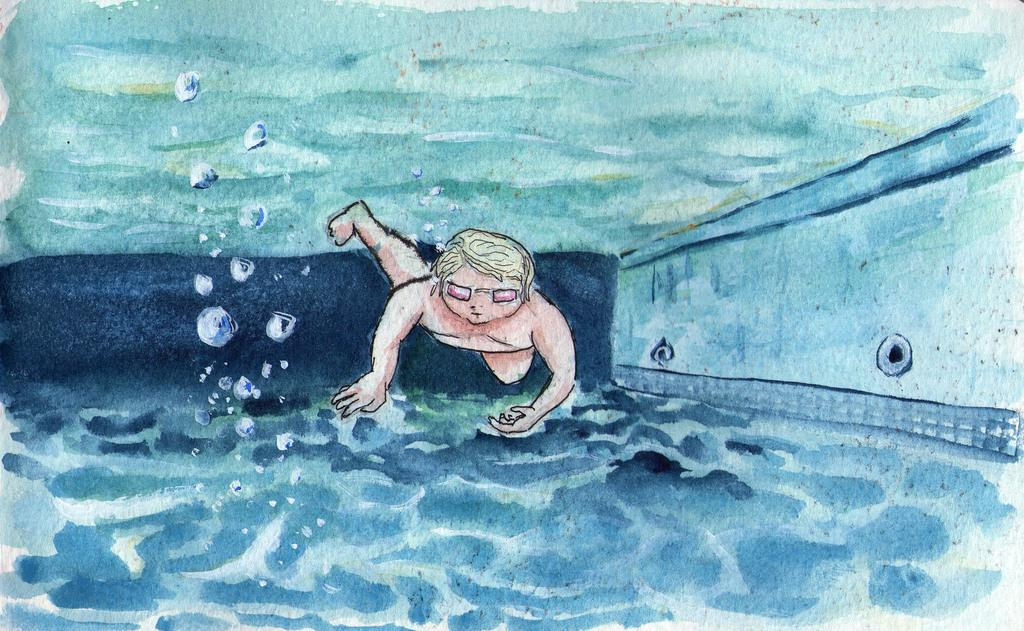What is the main subject of the painting in the image? The painting depicts a person swimming. Where is the person swimming in the painting? The person is swimming in a pool. What type of patch is visible on the person's toothpaste in the image? There is no toothpaste or patch present in the image; it features a painting of a person swimming in a pool. 